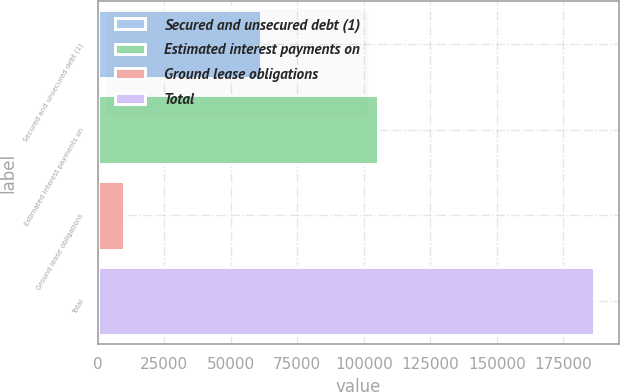<chart> <loc_0><loc_0><loc_500><loc_500><bar_chart><fcel>Secured and unsecured debt (1)<fcel>Estimated interest payments on<fcel>Ground lease obligations<fcel>Total<nl><fcel>61190<fcel>105205<fcel>9828<fcel>186573<nl></chart> 